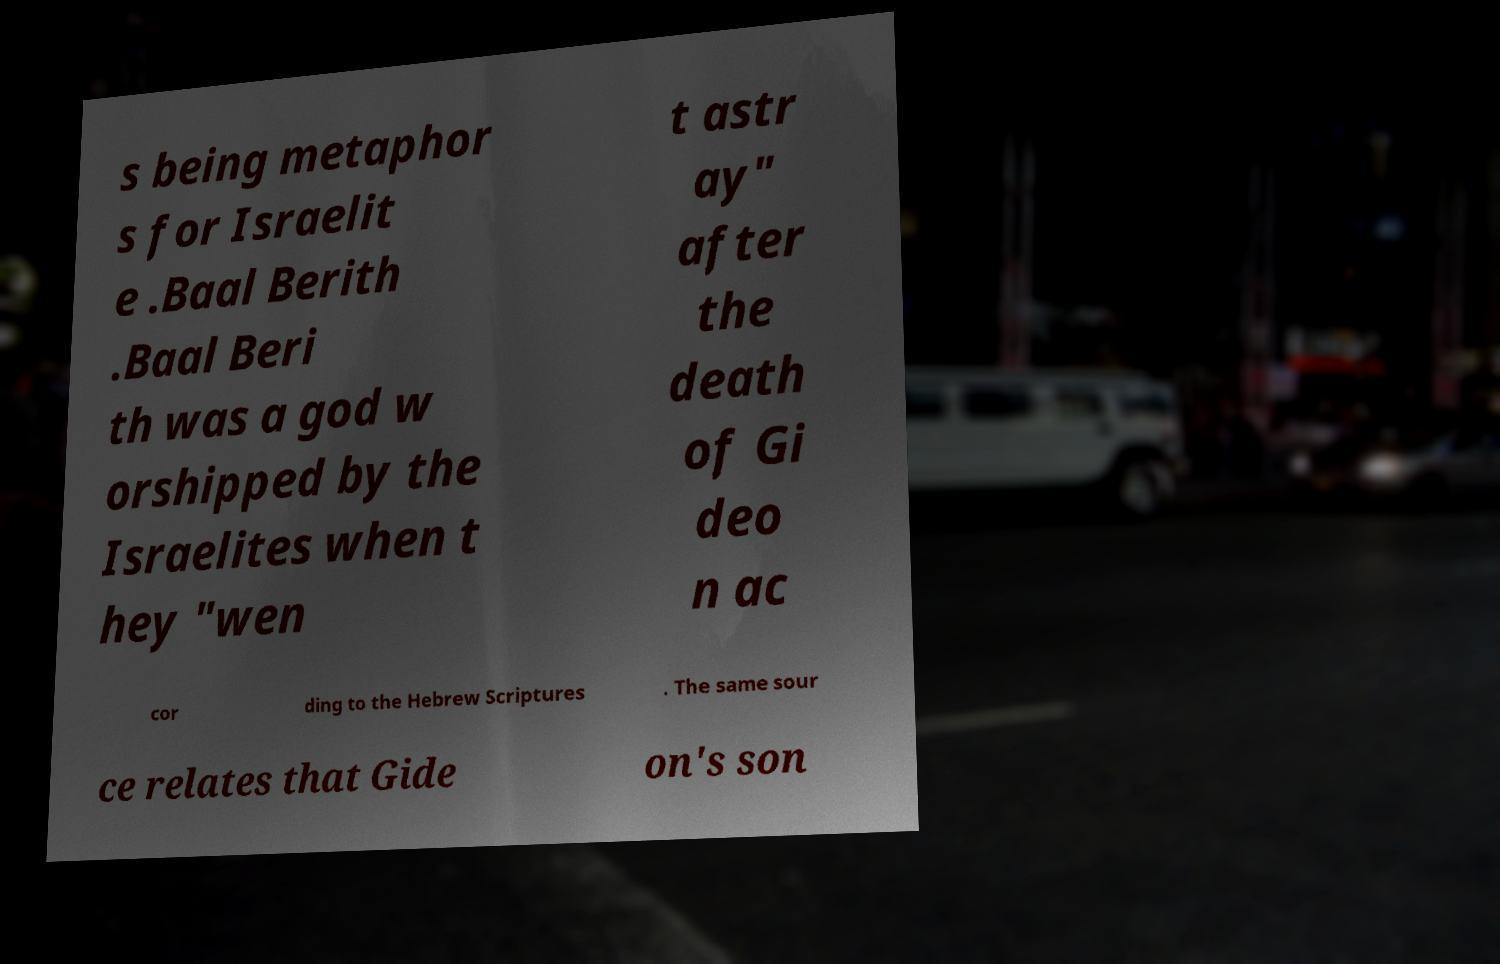There's text embedded in this image that I need extracted. Can you transcribe it verbatim? s being metaphor s for Israelit e .Baal Berith .Baal Beri th was a god w orshipped by the Israelites when t hey "wen t astr ay" after the death of Gi deo n ac cor ding to the Hebrew Scriptures . The same sour ce relates that Gide on's son 